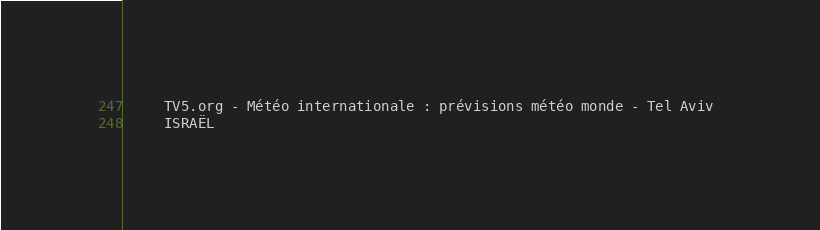<code> <loc_0><loc_0><loc_500><loc_500><_XML_>	 TV5.org - Météo internationale : prévisions météo monde - Tel Aviv 
	 ISRAËL 
</code> 